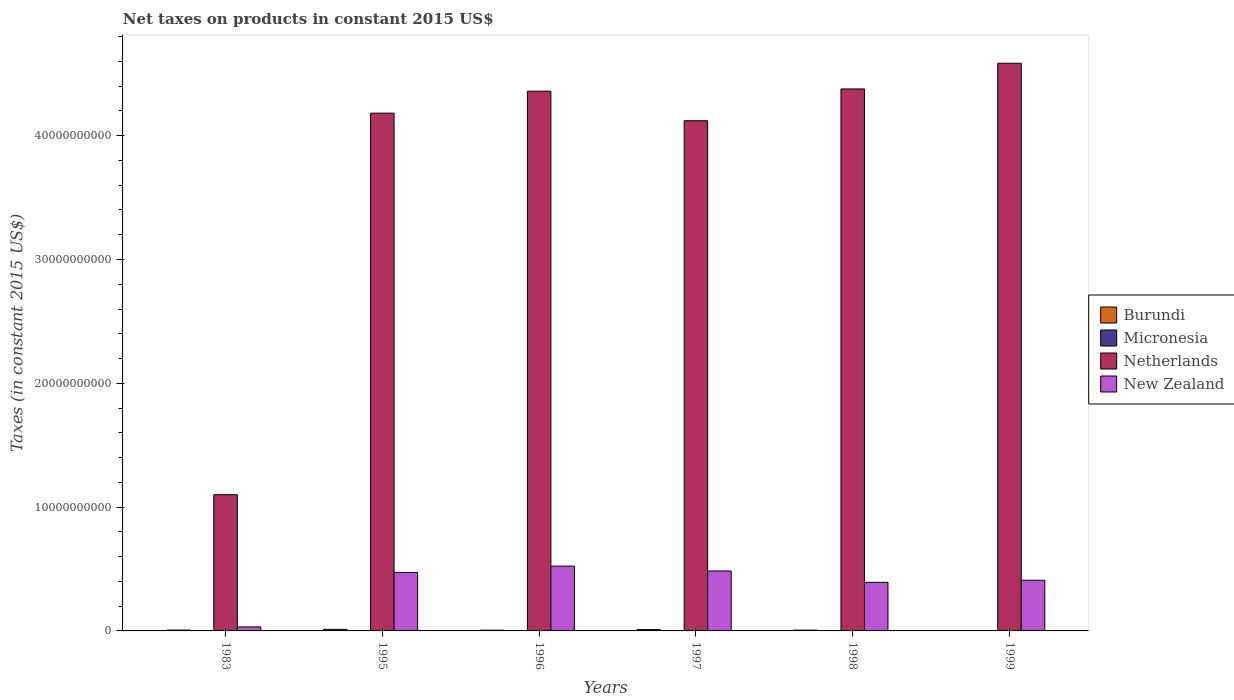How many different coloured bars are there?
Keep it short and to the point. 4. How many groups of bars are there?
Give a very brief answer. 6. Are the number of bars on each tick of the X-axis equal?
Provide a succinct answer. Yes. What is the label of the 2nd group of bars from the left?
Provide a short and direct response. 1995. What is the net taxes on products in Burundi in 1996?
Keep it short and to the point. 5.83e+07. Across all years, what is the maximum net taxes on products in New Zealand?
Provide a succinct answer. 5.23e+09. Across all years, what is the minimum net taxes on products in Micronesia?
Make the answer very short. 5.70e+06. In which year was the net taxes on products in Micronesia maximum?
Keep it short and to the point. 1999. In which year was the net taxes on products in Burundi minimum?
Offer a terse response. 1999. What is the total net taxes on products in Burundi in the graph?
Make the answer very short. 4.34e+08. What is the difference between the net taxes on products in Netherlands in 1995 and that in 1997?
Offer a terse response. 6.10e+08. What is the difference between the net taxes on products in New Zealand in 1983 and the net taxes on products in Burundi in 1995?
Your response must be concise. 1.97e+08. What is the average net taxes on products in New Zealand per year?
Keep it short and to the point. 3.86e+09. In the year 1983, what is the difference between the net taxes on products in Burundi and net taxes on products in Netherlands?
Make the answer very short. -1.09e+1. In how many years, is the net taxes on products in Micronesia greater than 10000000000 US$?
Provide a short and direct response. 0. What is the ratio of the net taxes on products in Burundi in 1983 to that in 1995?
Offer a very short reply. 0.56. What is the difference between the highest and the second highest net taxes on products in Micronesia?
Ensure brevity in your answer.  1.82e+06. What is the difference between the highest and the lowest net taxes on products in Micronesia?
Ensure brevity in your answer.  7.96e+06. In how many years, is the net taxes on products in New Zealand greater than the average net taxes on products in New Zealand taken over all years?
Your answer should be compact. 5. Is the sum of the net taxes on products in Micronesia in 1998 and 1999 greater than the maximum net taxes on products in Netherlands across all years?
Provide a succinct answer. No. Is it the case that in every year, the sum of the net taxes on products in Netherlands and net taxes on products in New Zealand is greater than the sum of net taxes on products in Micronesia and net taxes on products in Burundi?
Provide a short and direct response. No. What does the 3rd bar from the left in 1997 represents?
Ensure brevity in your answer.  Netherlands. What does the 3rd bar from the right in 1983 represents?
Keep it short and to the point. Micronesia. Are all the bars in the graph horizontal?
Make the answer very short. No. How many years are there in the graph?
Make the answer very short. 6. Are the values on the major ticks of Y-axis written in scientific E-notation?
Offer a terse response. No. Does the graph contain any zero values?
Provide a short and direct response. No. Where does the legend appear in the graph?
Offer a terse response. Center right. What is the title of the graph?
Your answer should be compact. Net taxes on products in constant 2015 US$. What is the label or title of the Y-axis?
Make the answer very short. Taxes (in constant 2015 US$). What is the Taxes (in constant 2015 US$) in Burundi in 1983?
Provide a short and direct response. 7.12e+07. What is the Taxes (in constant 2015 US$) of Micronesia in 1983?
Keep it short and to the point. 5.70e+06. What is the Taxes (in constant 2015 US$) in Netherlands in 1983?
Ensure brevity in your answer.  1.10e+1. What is the Taxes (in constant 2015 US$) of New Zealand in 1983?
Your answer should be compact. 3.24e+08. What is the Taxes (in constant 2015 US$) of Burundi in 1995?
Ensure brevity in your answer.  1.27e+08. What is the Taxes (in constant 2015 US$) of Micronesia in 1995?
Provide a short and direct response. 1.10e+07. What is the Taxes (in constant 2015 US$) in Netherlands in 1995?
Keep it short and to the point. 4.18e+1. What is the Taxes (in constant 2015 US$) of New Zealand in 1995?
Offer a terse response. 4.73e+09. What is the Taxes (in constant 2015 US$) in Burundi in 1996?
Provide a short and direct response. 5.83e+07. What is the Taxes (in constant 2015 US$) in Micronesia in 1996?
Your answer should be compact. 8.94e+06. What is the Taxes (in constant 2015 US$) of Netherlands in 1996?
Your answer should be compact. 4.36e+1. What is the Taxes (in constant 2015 US$) of New Zealand in 1996?
Your response must be concise. 5.23e+09. What is the Taxes (in constant 2015 US$) of Burundi in 1997?
Provide a succinct answer. 1.08e+08. What is the Taxes (in constant 2015 US$) of Micronesia in 1997?
Offer a terse response. 1.00e+07. What is the Taxes (in constant 2015 US$) in Netherlands in 1997?
Your answer should be very brief. 4.12e+1. What is the Taxes (in constant 2015 US$) in New Zealand in 1997?
Ensure brevity in your answer.  4.84e+09. What is the Taxes (in constant 2015 US$) of Burundi in 1998?
Offer a very short reply. 6.50e+07. What is the Taxes (in constant 2015 US$) in Micronesia in 1998?
Keep it short and to the point. 1.18e+07. What is the Taxes (in constant 2015 US$) of Netherlands in 1998?
Offer a very short reply. 4.38e+1. What is the Taxes (in constant 2015 US$) of New Zealand in 1998?
Your answer should be compact. 3.92e+09. What is the Taxes (in constant 2015 US$) in Burundi in 1999?
Make the answer very short. 4.30e+06. What is the Taxes (in constant 2015 US$) in Micronesia in 1999?
Provide a short and direct response. 1.37e+07. What is the Taxes (in constant 2015 US$) of Netherlands in 1999?
Provide a succinct answer. 4.58e+1. What is the Taxes (in constant 2015 US$) of New Zealand in 1999?
Keep it short and to the point. 4.09e+09. Across all years, what is the maximum Taxes (in constant 2015 US$) in Burundi?
Keep it short and to the point. 1.27e+08. Across all years, what is the maximum Taxes (in constant 2015 US$) of Micronesia?
Make the answer very short. 1.37e+07. Across all years, what is the maximum Taxes (in constant 2015 US$) in Netherlands?
Keep it short and to the point. 4.58e+1. Across all years, what is the maximum Taxes (in constant 2015 US$) in New Zealand?
Your answer should be very brief. 5.23e+09. Across all years, what is the minimum Taxes (in constant 2015 US$) in Burundi?
Offer a terse response. 4.30e+06. Across all years, what is the minimum Taxes (in constant 2015 US$) in Micronesia?
Give a very brief answer. 5.70e+06. Across all years, what is the minimum Taxes (in constant 2015 US$) in Netherlands?
Your answer should be compact. 1.10e+1. Across all years, what is the minimum Taxes (in constant 2015 US$) of New Zealand?
Offer a very short reply. 3.24e+08. What is the total Taxes (in constant 2015 US$) in Burundi in the graph?
Your answer should be compact. 4.34e+08. What is the total Taxes (in constant 2015 US$) in Micronesia in the graph?
Your answer should be compact. 6.12e+07. What is the total Taxes (in constant 2015 US$) of Netherlands in the graph?
Offer a terse response. 2.27e+11. What is the total Taxes (in constant 2015 US$) in New Zealand in the graph?
Give a very brief answer. 2.31e+1. What is the difference between the Taxes (in constant 2015 US$) of Burundi in 1983 and that in 1995?
Make the answer very short. -5.60e+07. What is the difference between the Taxes (in constant 2015 US$) in Micronesia in 1983 and that in 1995?
Keep it short and to the point. -5.30e+06. What is the difference between the Taxes (in constant 2015 US$) of Netherlands in 1983 and that in 1995?
Offer a terse response. -3.08e+1. What is the difference between the Taxes (in constant 2015 US$) in New Zealand in 1983 and that in 1995?
Offer a very short reply. -4.40e+09. What is the difference between the Taxes (in constant 2015 US$) of Burundi in 1983 and that in 1996?
Keep it short and to the point. 1.29e+07. What is the difference between the Taxes (in constant 2015 US$) of Micronesia in 1983 and that in 1996?
Offer a very short reply. -3.24e+06. What is the difference between the Taxes (in constant 2015 US$) of Netherlands in 1983 and that in 1996?
Ensure brevity in your answer.  -3.26e+1. What is the difference between the Taxes (in constant 2015 US$) in New Zealand in 1983 and that in 1996?
Make the answer very short. -4.91e+09. What is the difference between the Taxes (in constant 2015 US$) of Burundi in 1983 and that in 1997?
Ensure brevity in your answer.  -3.69e+07. What is the difference between the Taxes (in constant 2015 US$) in Micronesia in 1983 and that in 1997?
Offer a very short reply. -4.31e+06. What is the difference between the Taxes (in constant 2015 US$) in Netherlands in 1983 and that in 1997?
Provide a short and direct response. -3.02e+1. What is the difference between the Taxes (in constant 2015 US$) in New Zealand in 1983 and that in 1997?
Your answer should be compact. -4.52e+09. What is the difference between the Taxes (in constant 2015 US$) in Burundi in 1983 and that in 1998?
Make the answer very short. 6.21e+06. What is the difference between the Taxes (in constant 2015 US$) of Micronesia in 1983 and that in 1998?
Offer a terse response. -6.14e+06. What is the difference between the Taxes (in constant 2015 US$) in Netherlands in 1983 and that in 1998?
Give a very brief answer. -3.28e+1. What is the difference between the Taxes (in constant 2015 US$) of New Zealand in 1983 and that in 1998?
Give a very brief answer. -3.60e+09. What is the difference between the Taxes (in constant 2015 US$) in Burundi in 1983 and that in 1999?
Keep it short and to the point. 6.69e+07. What is the difference between the Taxes (in constant 2015 US$) of Micronesia in 1983 and that in 1999?
Keep it short and to the point. -7.96e+06. What is the difference between the Taxes (in constant 2015 US$) in Netherlands in 1983 and that in 1999?
Your answer should be very brief. -3.48e+1. What is the difference between the Taxes (in constant 2015 US$) in New Zealand in 1983 and that in 1999?
Give a very brief answer. -3.77e+09. What is the difference between the Taxes (in constant 2015 US$) in Burundi in 1995 and that in 1996?
Offer a terse response. 6.89e+07. What is the difference between the Taxes (in constant 2015 US$) of Micronesia in 1995 and that in 1996?
Give a very brief answer. 2.06e+06. What is the difference between the Taxes (in constant 2015 US$) in Netherlands in 1995 and that in 1996?
Make the answer very short. -1.78e+09. What is the difference between the Taxes (in constant 2015 US$) in New Zealand in 1995 and that in 1996?
Make the answer very short. -5.06e+08. What is the difference between the Taxes (in constant 2015 US$) in Burundi in 1995 and that in 1997?
Offer a terse response. 1.91e+07. What is the difference between the Taxes (in constant 2015 US$) of Micronesia in 1995 and that in 1997?
Offer a very short reply. 9.87e+05. What is the difference between the Taxes (in constant 2015 US$) in Netherlands in 1995 and that in 1997?
Provide a succinct answer. 6.10e+08. What is the difference between the Taxes (in constant 2015 US$) of New Zealand in 1995 and that in 1997?
Offer a terse response. -1.17e+08. What is the difference between the Taxes (in constant 2015 US$) of Burundi in 1995 and that in 1998?
Offer a very short reply. 6.22e+07. What is the difference between the Taxes (in constant 2015 US$) in Micronesia in 1995 and that in 1998?
Give a very brief answer. -8.42e+05. What is the difference between the Taxes (in constant 2015 US$) in Netherlands in 1995 and that in 1998?
Your answer should be very brief. -1.96e+09. What is the difference between the Taxes (in constant 2015 US$) in New Zealand in 1995 and that in 1998?
Your answer should be compact. 8.03e+08. What is the difference between the Taxes (in constant 2015 US$) in Burundi in 1995 and that in 1999?
Offer a very short reply. 1.23e+08. What is the difference between the Taxes (in constant 2015 US$) in Micronesia in 1995 and that in 1999?
Provide a short and direct response. -2.66e+06. What is the difference between the Taxes (in constant 2015 US$) in Netherlands in 1995 and that in 1999?
Your response must be concise. -4.03e+09. What is the difference between the Taxes (in constant 2015 US$) of New Zealand in 1995 and that in 1999?
Your response must be concise. 6.34e+08. What is the difference between the Taxes (in constant 2015 US$) in Burundi in 1996 and that in 1997?
Your answer should be compact. -4.98e+07. What is the difference between the Taxes (in constant 2015 US$) of Micronesia in 1996 and that in 1997?
Offer a very short reply. -1.07e+06. What is the difference between the Taxes (in constant 2015 US$) of Netherlands in 1996 and that in 1997?
Make the answer very short. 2.39e+09. What is the difference between the Taxes (in constant 2015 US$) of New Zealand in 1996 and that in 1997?
Your answer should be compact. 3.89e+08. What is the difference between the Taxes (in constant 2015 US$) in Burundi in 1996 and that in 1998?
Keep it short and to the point. -6.66e+06. What is the difference between the Taxes (in constant 2015 US$) of Micronesia in 1996 and that in 1998?
Provide a succinct answer. -2.90e+06. What is the difference between the Taxes (in constant 2015 US$) of Netherlands in 1996 and that in 1998?
Ensure brevity in your answer.  -1.81e+08. What is the difference between the Taxes (in constant 2015 US$) of New Zealand in 1996 and that in 1998?
Your response must be concise. 1.31e+09. What is the difference between the Taxes (in constant 2015 US$) of Burundi in 1996 and that in 1999?
Your answer should be compact. 5.40e+07. What is the difference between the Taxes (in constant 2015 US$) in Micronesia in 1996 and that in 1999?
Make the answer very short. -4.72e+06. What is the difference between the Taxes (in constant 2015 US$) in Netherlands in 1996 and that in 1999?
Offer a very short reply. -2.25e+09. What is the difference between the Taxes (in constant 2015 US$) of New Zealand in 1996 and that in 1999?
Provide a succinct answer. 1.14e+09. What is the difference between the Taxes (in constant 2015 US$) in Burundi in 1997 and that in 1998?
Your answer should be compact. 4.32e+07. What is the difference between the Taxes (in constant 2015 US$) of Micronesia in 1997 and that in 1998?
Your answer should be compact. -1.83e+06. What is the difference between the Taxes (in constant 2015 US$) in Netherlands in 1997 and that in 1998?
Make the answer very short. -2.57e+09. What is the difference between the Taxes (in constant 2015 US$) in New Zealand in 1997 and that in 1998?
Offer a terse response. 9.21e+08. What is the difference between the Taxes (in constant 2015 US$) of Burundi in 1997 and that in 1999?
Provide a succinct answer. 1.04e+08. What is the difference between the Taxes (in constant 2015 US$) in Micronesia in 1997 and that in 1999?
Make the answer very short. -3.65e+06. What is the difference between the Taxes (in constant 2015 US$) in Netherlands in 1997 and that in 1999?
Make the answer very short. -4.64e+09. What is the difference between the Taxes (in constant 2015 US$) in New Zealand in 1997 and that in 1999?
Offer a terse response. 7.51e+08. What is the difference between the Taxes (in constant 2015 US$) of Burundi in 1998 and that in 1999?
Give a very brief answer. 6.07e+07. What is the difference between the Taxes (in constant 2015 US$) in Micronesia in 1998 and that in 1999?
Your response must be concise. -1.82e+06. What is the difference between the Taxes (in constant 2015 US$) in Netherlands in 1998 and that in 1999?
Ensure brevity in your answer.  -2.07e+09. What is the difference between the Taxes (in constant 2015 US$) in New Zealand in 1998 and that in 1999?
Offer a very short reply. -1.69e+08. What is the difference between the Taxes (in constant 2015 US$) in Burundi in 1983 and the Taxes (in constant 2015 US$) in Micronesia in 1995?
Your answer should be compact. 6.02e+07. What is the difference between the Taxes (in constant 2015 US$) of Burundi in 1983 and the Taxes (in constant 2015 US$) of Netherlands in 1995?
Provide a succinct answer. -4.17e+1. What is the difference between the Taxes (in constant 2015 US$) of Burundi in 1983 and the Taxes (in constant 2015 US$) of New Zealand in 1995?
Give a very brief answer. -4.65e+09. What is the difference between the Taxes (in constant 2015 US$) of Micronesia in 1983 and the Taxes (in constant 2015 US$) of Netherlands in 1995?
Offer a terse response. -4.18e+1. What is the difference between the Taxes (in constant 2015 US$) of Micronesia in 1983 and the Taxes (in constant 2015 US$) of New Zealand in 1995?
Your answer should be very brief. -4.72e+09. What is the difference between the Taxes (in constant 2015 US$) of Netherlands in 1983 and the Taxes (in constant 2015 US$) of New Zealand in 1995?
Give a very brief answer. 6.28e+09. What is the difference between the Taxes (in constant 2015 US$) of Burundi in 1983 and the Taxes (in constant 2015 US$) of Micronesia in 1996?
Give a very brief answer. 6.23e+07. What is the difference between the Taxes (in constant 2015 US$) in Burundi in 1983 and the Taxes (in constant 2015 US$) in Netherlands in 1996?
Your answer should be compact. -4.35e+1. What is the difference between the Taxes (in constant 2015 US$) of Burundi in 1983 and the Taxes (in constant 2015 US$) of New Zealand in 1996?
Provide a short and direct response. -5.16e+09. What is the difference between the Taxes (in constant 2015 US$) of Micronesia in 1983 and the Taxes (in constant 2015 US$) of Netherlands in 1996?
Your response must be concise. -4.36e+1. What is the difference between the Taxes (in constant 2015 US$) of Micronesia in 1983 and the Taxes (in constant 2015 US$) of New Zealand in 1996?
Ensure brevity in your answer.  -5.23e+09. What is the difference between the Taxes (in constant 2015 US$) of Netherlands in 1983 and the Taxes (in constant 2015 US$) of New Zealand in 1996?
Give a very brief answer. 5.77e+09. What is the difference between the Taxes (in constant 2015 US$) in Burundi in 1983 and the Taxes (in constant 2015 US$) in Micronesia in 1997?
Your answer should be compact. 6.12e+07. What is the difference between the Taxes (in constant 2015 US$) in Burundi in 1983 and the Taxes (in constant 2015 US$) in Netherlands in 1997?
Provide a short and direct response. -4.11e+1. What is the difference between the Taxes (in constant 2015 US$) in Burundi in 1983 and the Taxes (in constant 2015 US$) in New Zealand in 1997?
Keep it short and to the point. -4.77e+09. What is the difference between the Taxes (in constant 2015 US$) of Micronesia in 1983 and the Taxes (in constant 2015 US$) of Netherlands in 1997?
Ensure brevity in your answer.  -4.12e+1. What is the difference between the Taxes (in constant 2015 US$) in Micronesia in 1983 and the Taxes (in constant 2015 US$) in New Zealand in 1997?
Your answer should be very brief. -4.84e+09. What is the difference between the Taxes (in constant 2015 US$) in Netherlands in 1983 and the Taxes (in constant 2015 US$) in New Zealand in 1997?
Give a very brief answer. 6.16e+09. What is the difference between the Taxes (in constant 2015 US$) in Burundi in 1983 and the Taxes (in constant 2015 US$) in Micronesia in 1998?
Offer a terse response. 5.94e+07. What is the difference between the Taxes (in constant 2015 US$) in Burundi in 1983 and the Taxes (in constant 2015 US$) in Netherlands in 1998?
Offer a terse response. -4.37e+1. What is the difference between the Taxes (in constant 2015 US$) in Burundi in 1983 and the Taxes (in constant 2015 US$) in New Zealand in 1998?
Provide a succinct answer. -3.85e+09. What is the difference between the Taxes (in constant 2015 US$) in Micronesia in 1983 and the Taxes (in constant 2015 US$) in Netherlands in 1998?
Your answer should be very brief. -4.38e+1. What is the difference between the Taxes (in constant 2015 US$) in Micronesia in 1983 and the Taxes (in constant 2015 US$) in New Zealand in 1998?
Your answer should be compact. -3.92e+09. What is the difference between the Taxes (in constant 2015 US$) in Netherlands in 1983 and the Taxes (in constant 2015 US$) in New Zealand in 1998?
Keep it short and to the point. 7.08e+09. What is the difference between the Taxes (in constant 2015 US$) in Burundi in 1983 and the Taxes (in constant 2015 US$) in Micronesia in 1999?
Your answer should be very brief. 5.75e+07. What is the difference between the Taxes (in constant 2015 US$) in Burundi in 1983 and the Taxes (in constant 2015 US$) in Netherlands in 1999?
Make the answer very short. -4.58e+1. What is the difference between the Taxes (in constant 2015 US$) of Burundi in 1983 and the Taxes (in constant 2015 US$) of New Zealand in 1999?
Your answer should be compact. -4.02e+09. What is the difference between the Taxes (in constant 2015 US$) of Micronesia in 1983 and the Taxes (in constant 2015 US$) of Netherlands in 1999?
Give a very brief answer. -4.58e+1. What is the difference between the Taxes (in constant 2015 US$) in Micronesia in 1983 and the Taxes (in constant 2015 US$) in New Zealand in 1999?
Your answer should be very brief. -4.09e+09. What is the difference between the Taxes (in constant 2015 US$) of Netherlands in 1983 and the Taxes (in constant 2015 US$) of New Zealand in 1999?
Provide a short and direct response. 6.91e+09. What is the difference between the Taxes (in constant 2015 US$) in Burundi in 1995 and the Taxes (in constant 2015 US$) in Micronesia in 1996?
Give a very brief answer. 1.18e+08. What is the difference between the Taxes (in constant 2015 US$) in Burundi in 1995 and the Taxes (in constant 2015 US$) in Netherlands in 1996?
Your answer should be very brief. -4.35e+1. What is the difference between the Taxes (in constant 2015 US$) in Burundi in 1995 and the Taxes (in constant 2015 US$) in New Zealand in 1996?
Make the answer very short. -5.10e+09. What is the difference between the Taxes (in constant 2015 US$) in Micronesia in 1995 and the Taxes (in constant 2015 US$) in Netherlands in 1996?
Provide a short and direct response. -4.36e+1. What is the difference between the Taxes (in constant 2015 US$) in Micronesia in 1995 and the Taxes (in constant 2015 US$) in New Zealand in 1996?
Your answer should be very brief. -5.22e+09. What is the difference between the Taxes (in constant 2015 US$) in Netherlands in 1995 and the Taxes (in constant 2015 US$) in New Zealand in 1996?
Offer a very short reply. 3.66e+1. What is the difference between the Taxes (in constant 2015 US$) in Burundi in 1995 and the Taxes (in constant 2015 US$) in Micronesia in 1997?
Keep it short and to the point. 1.17e+08. What is the difference between the Taxes (in constant 2015 US$) in Burundi in 1995 and the Taxes (in constant 2015 US$) in Netherlands in 1997?
Offer a terse response. -4.11e+1. What is the difference between the Taxes (in constant 2015 US$) of Burundi in 1995 and the Taxes (in constant 2015 US$) of New Zealand in 1997?
Provide a short and direct response. -4.72e+09. What is the difference between the Taxes (in constant 2015 US$) in Micronesia in 1995 and the Taxes (in constant 2015 US$) in Netherlands in 1997?
Your response must be concise. -4.12e+1. What is the difference between the Taxes (in constant 2015 US$) of Micronesia in 1995 and the Taxes (in constant 2015 US$) of New Zealand in 1997?
Keep it short and to the point. -4.83e+09. What is the difference between the Taxes (in constant 2015 US$) of Netherlands in 1995 and the Taxes (in constant 2015 US$) of New Zealand in 1997?
Your answer should be compact. 3.70e+1. What is the difference between the Taxes (in constant 2015 US$) of Burundi in 1995 and the Taxes (in constant 2015 US$) of Micronesia in 1998?
Make the answer very short. 1.15e+08. What is the difference between the Taxes (in constant 2015 US$) in Burundi in 1995 and the Taxes (in constant 2015 US$) in Netherlands in 1998?
Your answer should be compact. -4.36e+1. What is the difference between the Taxes (in constant 2015 US$) in Burundi in 1995 and the Taxes (in constant 2015 US$) in New Zealand in 1998?
Your answer should be very brief. -3.80e+09. What is the difference between the Taxes (in constant 2015 US$) in Micronesia in 1995 and the Taxes (in constant 2015 US$) in Netherlands in 1998?
Offer a terse response. -4.38e+1. What is the difference between the Taxes (in constant 2015 US$) of Micronesia in 1995 and the Taxes (in constant 2015 US$) of New Zealand in 1998?
Offer a very short reply. -3.91e+09. What is the difference between the Taxes (in constant 2015 US$) in Netherlands in 1995 and the Taxes (in constant 2015 US$) in New Zealand in 1998?
Offer a very short reply. 3.79e+1. What is the difference between the Taxes (in constant 2015 US$) in Burundi in 1995 and the Taxes (in constant 2015 US$) in Micronesia in 1999?
Your answer should be very brief. 1.14e+08. What is the difference between the Taxes (in constant 2015 US$) in Burundi in 1995 and the Taxes (in constant 2015 US$) in Netherlands in 1999?
Your answer should be very brief. -4.57e+1. What is the difference between the Taxes (in constant 2015 US$) in Burundi in 1995 and the Taxes (in constant 2015 US$) in New Zealand in 1999?
Offer a very short reply. -3.96e+09. What is the difference between the Taxes (in constant 2015 US$) of Micronesia in 1995 and the Taxes (in constant 2015 US$) of Netherlands in 1999?
Your answer should be compact. -4.58e+1. What is the difference between the Taxes (in constant 2015 US$) in Micronesia in 1995 and the Taxes (in constant 2015 US$) in New Zealand in 1999?
Your answer should be compact. -4.08e+09. What is the difference between the Taxes (in constant 2015 US$) of Netherlands in 1995 and the Taxes (in constant 2015 US$) of New Zealand in 1999?
Offer a terse response. 3.77e+1. What is the difference between the Taxes (in constant 2015 US$) in Burundi in 1996 and the Taxes (in constant 2015 US$) in Micronesia in 1997?
Offer a very short reply. 4.83e+07. What is the difference between the Taxes (in constant 2015 US$) of Burundi in 1996 and the Taxes (in constant 2015 US$) of Netherlands in 1997?
Offer a very short reply. -4.11e+1. What is the difference between the Taxes (in constant 2015 US$) of Burundi in 1996 and the Taxes (in constant 2015 US$) of New Zealand in 1997?
Offer a very short reply. -4.78e+09. What is the difference between the Taxes (in constant 2015 US$) of Micronesia in 1996 and the Taxes (in constant 2015 US$) of Netherlands in 1997?
Your answer should be compact. -4.12e+1. What is the difference between the Taxes (in constant 2015 US$) in Micronesia in 1996 and the Taxes (in constant 2015 US$) in New Zealand in 1997?
Your response must be concise. -4.83e+09. What is the difference between the Taxes (in constant 2015 US$) in Netherlands in 1996 and the Taxes (in constant 2015 US$) in New Zealand in 1997?
Give a very brief answer. 3.88e+1. What is the difference between the Taxes (in constant 2015 US$) of Burundi in 1996 and the Taxes (in constant 2015 US$) of Micronesia in 1998?
Ensure brevity in your answer.  4.65e+07. What is the difference between the Taxes (in constant 2015 US$) of Burundi in 1996 and the Taxes (in constant 2015 US$) of Netherlands in 1998?
Your answer should be compact. -4.37e+1. What is the difference between the Taxes (in constant 2015 US$) in Burundi in 1996 and the Taxes (in constant 2015 US$) in New Zealand in 1998?
Offer a terse response. -3.86e+09. What is the difference between the Taxes (in constant 2015 US$) in Micronesia in 1996 and the Taxes (in constant 2015 US$) in Netherlands in 1998?
Keep it short and to the point. -4.38e+1. What is the difference between the Taxes (in constant 2015 US$) in Micronesia in 1996 and the Taxes (in constant 2015 US$) in New Zealand in 1998?
Make the answer very short. -3.91e+09. What is the difference between the Taxes (in constant 2015 US$) of Netherlands in 1996 and the Taxes (in constant 2015 US$) of New Zealand in 1998?
Provide a short and direct response. 3.97e+1. What is the difference between the Taxes (in constant 2015 US$) of Burundi in 1996 and the Taxes (in constant 2015 US$) of Micronesia in 1999?
Provide a short and direct response. 4.47e+07. What is the difference between the Taxes (in constant 2015 US$) in Burundi in 1996 and the Taxes (in constant 2015 US$) in Netherlands in 1999?
Provide a short and direct response. -4.58e+1. What is the difference between the Taxes (in constant 2015 US$) in Burundi in 1996 and the Taxes (in constant 2015 US$) in New Zealand in 1999?
Your answer should be very brief. -4.03e+09. What is the difference between the Taxes (in constant 2015 US$) of Micronesia in 1996 and the Taxes (in constant 2015 US$) of Netherlands in 1999?
Your response must be concise. -4.58e+1. What is the difference between the Taxes (in constant 2015 US$) of Micronesia in 1996 and the Taxes (in constant 2015 US$) of New Zealand in 1999?
Make the answer very short. -4.08e+09. What is the difference between the Taxes (in constant 2015 US$) of Netherlands in 1996 and the Taxes (in constant 2015 US$) of New Zealand in 1999?
Offer a very short reply. 3.95e+1. What is the difference between the Taxes (in constant 2015 US$) of Burundi in 1997 and the Taxes (in constant 2015 US$) of Micronesia in 1998?
Offer a terse response. 9.63e+07. What is the difference between the Taxes (in constant 2015 US$) in Burundi in 1997 and the Taxes (in constant 2015 US$) in Netherlands in 1998?
Your answer should be compact. -4.37e+1. What is the difference between the Taxes (in constant 2015 US$) in Burundi in 1997 and the Taxes (in constant 2015 US$) in New Zealand in 1998?
Make the answer very short. -3.81e+09. What is the difference between the Taxes (in constant 2015 US$) in Micronesia in 1997 and the Taxes (in constant 2015 US$) in Netherlands in 1998?
Offer a very short reply. -4.38e+1. What is the difference between the Taxes (in constant 2015 US$) of Micronesia in 1997 and the Taxes (in constant 2015 US$) of New Zealand in 1998?
Your answer should be very brief. -3.91e+09. What is the difference between the Taxes (in constant 2015 US$) of Netherlands in 1997 and the Taxes (in constant 2015 US$) of New Zealand in 1998?
Your response must be concise. 3.73e+1. What is the difference between the Taxes (in constant 2015 US$) in Burundi in 1997 and the Taxes (in constant 2015 US$) in Micronesia in 1999?
Ensure brevity in your answer.  9.45e+07. What is the difference between the Taxes (in constant 2015 US$) of Burundi in 1997 and the Taxes (in constant 2015 US$) of Netherlands in 1999?
Make the answer very short. -4.57e+1. What is the difference between the Taxes (in constant 2015 US$) of Burundi in 1997 and the Taxes (in constant 2015 US$) of New Zealand in 1999?
Give a very brief answer. -3.98e+09. What is the difference between the Taxes (in constant 2015 US$) of Micronesia in 1997 and the Taxes (in constant 2015 US$) of Netherlands in 1999?
Make the answer very short. -4.58e+1. What is the difference between the Taxes (in constant 2015 US$) in Micronesia in 1997 and the Taxes (in constant 2015 US$) in New Zealand in 1999?
Offer a terse response. -4.08e+09. What is the difference between the Taxes (in constant 2015 US$) of Netherlands in 1997 and the Taxes (in constant 2015 US$) of New Zealand in 1999?
Ensure brevity in your answer.  3.71e+1. What is the difference between the Taxes (in constant 2015 US$) of Burundi in 1998 and the Taxes (in constant 2015 US$) of Micronesia in 1999?
Offer a very short reply. 5.13e+07. What is the difference between the Taxes (in constant 2015 US$) in Burundi in 1998 and the Taxes (in constant 2015 US$) in Netherlands in 1999?
Provide a short and direct response. -4.58e+1. What is the difference between the Taxes (in constant 2015 US$) of Burundi in 1998 and the Taxes (in constant 2015 US$) of New Zealand in 1999?
Offer a terse response. -4.03e+09. What is the difference between the Taxes (in constant 2015 US$) of Micronesia in 1998 and the Taxes (in constant 2015 US$) of Netherlands in 1999?
Keep it short and to the point. -4.58e+1. What is the difference between the Taxes (in constant 2015 US$) in Micronesia in 1998 and the Taxes (in constant 2015 US$) in New Zealand in 1999?
Provide a short and direct response. -4.08e+09. What is the difference between the Taxes (in constant 2015 US$) of Netherlands in 1998 and the Taxes (in constant 2015 US$) of New Zealand in 1999?
Offer a very short reply. 3.97e+1. What is the average Taxes (in constant 2015 US$) of Burundi per year?
Offer a very short reply. 7.24e+07. What is the average Taxes (in constant 2015 US$) of Micronesia per year?
Keep it short and to the point. 1.02e+07. What is the average Taxes (in constant 2015 US$) in Netherlands per year?
Give a very brief answer. 3.79e+1. What is the average Taxes (in constant 2015 US$) of New Zealand per year?
Provide a short and direct response. 3.86e+09. In the year 1983, what is the difference between the Taxes (in constant 2015 US$) in Burundi and Taxes (in constant 2015 US$) in Micronesia?
Give a very brief answer. 6.55e+07. In the year 1983, what is the difference between the Taxes (in constant 2015 US$) in Burundi and Taxes (in constant 2015 US$) in Netherlands?
Give a very brief answer. -1.09e+1. In the year 1983, what is the difference between the Taxes (in constant 2015 US$) in Burundi and Taxes (in constant 2015 US$) in New Zealand?
Provide a short and direct response. -2.53e+08. In the year 1983, what is the difference between the Taxes (in constant 2015 US$) in Micronesia and Taxes (in constant 2015 US$) in Netherlands?
Your response must be concise. -1.10e+1. In the year 1983, what is the difference between the Taxes (in constant 2015 US$) of Micronesia and Taxes (in constant 2015 US$) of New Zealand?
Your answer should be very brief. -3.19e+08. In the year 1983, what is the difference between the Taxes (in constant 2015 US$) of Netherlands and Taxes (in constant 2015 US$) of New Zealand?
Ensure brevity in your answer.  1.07e+1. In the year 1995, what is the difference between the Taxes (in constant 2015 US$) of Burundi and Taxes (in constant 2015 US$) of Micronesia?
Make the answer very short. 1.16e+08. In the year 1995, what is the difference between the Taxes (in constant 2015 US$) of Burundi and Taxes (in constant 2015 US$) of Netherlands?
Offer a terse response. -4.17e+1. In the year 1995, what is the difference between the Taxes (in constant 2015 US$) in Burundi and Taxes (in constant 2015 US$) in New Zealand?
Give a very brief answer. -4.60e+09. In the year 1995, what is the difference between the Taxes (in constant 2015 US$) of Micronesia and Taxes (in constant 2015 US$) of Netherlands?
Keep it short and to the point. -4.18e+1. In the year 1995, what is the difference between the Taxes (in constant 2015 US$) of Micronesia and Taxes (in constant 2015 US$) of New Zealand?
Provide a succinct answer. -4.71e+09. In the year 1995, what is the difference between the Taxes (in constant 2015 US$) in Netherlands and Taxes (in constant 2015 US$) in New Zealand?
Keep it short and to the point. 3.71e+1. In the year 1996, what is the difference between the Taxes (in constant 2015 US$) in Burundi and Taxes (in constant 2015 US$) in Micronesia?
Give a very brief answer. 4.94e+07. In the year 1996, what is the difference between the Taxes (in constant 2015 US$) of Burundi and Taxes (in constant 2015 US$) of Netherlands?
Provide a short and direct response. -4.35e+1. In the year 1996, what is the difference between the Taxes (in constant 2015 US$) in Burundi and Taxes (in constant 2015 US$) in New Zealand?
Offer a very short reply. -5.17e+09. In the year 1996, what is the difference between the Taxes (in constant 2015 US$) in Micronesia and Taxes (in constant 2015 US$) in Netherlands?
Offer a very short reply. -4.36e+1. In the year 1996, what is the difference between the Taxes (in constant 2015 US$) in Micronesia and Taxes (in constant 2015 US$) in New Zealand?
Provide a short and direct response. -5.22e+09. In the year 1996, what is the difference between the Taxes (in constant 2015 US$) in Netherlands and Taxes (in constant 2015 US$) in New Zealand?
Keep it short and to the point. 3.84e+1. In the year 1997, what is the difference between the Taxes (in constant 2015 US$) in Burundi and Taxes (in constant 2015 US$) in Micronesia?
Make the answer very short. 9.81e+07. In the year 1997, what is the difference between the Taxes (in constant 2015 US$) in Burundi and Taxes (in constant 2015 US$) in Netherlands?
Your answer should be compact. -4.11e+1. In the year 1997, what is the difference between the Taxes (in constant 2015 US$) of Burundi and Taxes (in constant 2015 US$) of New Zealand?
Ensure brevity in your answer.  -4.74e+09. In the year 1997, what is the difference between the Taxes (in constant 2015 US$) of Micronesia and Taxes (in constant 2015 US$) of Netherlands?
Keep it short and to the point. -4.12e+1. In the year 1997, what is the difference between the Taxes (in constant 2015 US$) in Micronesia and Taxes (in constant 2015 US$) in New Zealand?
Offer a terse response. -4.83e+09. In the year 1997, what is the difference between the Taxes (in constant 2015 US$) in Netherlands and Taxes (in constant 2015 US$) in New Zealand?
Ensure brevity in your answer.  3.64e+1. In the year 1998, what is the difference between the Taxes (in constant 2015 US$) of Burundi and Taxes (in constant 2015 US$) of Micronesia?
Your response must be concise. 5.32e+07. In the year 1998, what is the difference between the Taxes (in constant 2015 US$) in Burundi and Taxes (in constant 2015 US$) in Netherlands?
Your answer should be compact. -4.37e+1. In the year 1998, what is the difference between the Taxes (in constant 2015 US$) in Burundi and Taxes (in constant 2015 US$) in New Zealand?
Provide a short and direct response. -3.86e+09. In the year 1998, what is the difference between the Taxes (in constant 2015 US$) in Micronesia and Taxes (in constant 2015 US$) in Netherlands?
Your answer should be compact. -4.38e+1. In the year 1998, what is the difference between the Taxes (in constant 2015 US$) in Micronesia and Taxes (in constant 2015 US$) in New Zealand?
Your answer should be very brief. -3.91e+09. In the year 1998, what is the difference between the Taxes (in constant 2015 US$) of Netherlands and Taxes (in constant 2015 US$) of New Zealand?
Make the answer very short. 3.99e+1. In the year 1999, what is the difference between the Taxes (in constant 2015 US$) in Burundi and Taxes (in constant 2015 US$) in Micronesia?
Your answer should be compact. -9.37e+06. In the year 1999, what is the difference between the Taxes (in constant 2015 US$) in Burundi and Taxes (in constant 2015 US$) in Netherlands?
Make the answer very short. -4.58e+1. In the year 1999, what is the difference between the Taxes (in constant 2015 US$) of Burundi and Taxes (in constant 2015 US$) of New Zealand?
Your response must be concise. -4.09e+09. In the year 1999, what is the difference between the Taxes (in constant 2015 US$) in Micronesia and Taxes (in constant 2015 US$) in Netherlands?
Your answer should be very brief. -4.58e+1. In the year 1999, what is the difference between the Taxes (in constant 2015 US$) of Micronesia and Taxes (in constant 2015 US$) of New Zealand?
Provide a short and direct response. -4.08e+09. In the year 1999, what is the difference between the Taxes (in constant 2015 US$) in Netherlands and Taxes (in constant 2015 US$) in New Zealand?
Offer a very short reply. 4.18e+1. What is the ratio of the Taxes (in constant 2015 US$) in Burundi in 1983 to that in 1995?
Your answer should be very brief. 0.56. What is the ratio of the Taxes (in constant 2015 US$) in Micronesia in 1983 to that in 1995?
Keep it short and to the point. 0.52. What is the ratio of the Taxes (in constant 2015 US$) of Netherlands in 1983 to that in 1995?
Ensure brevity in your answer.  0.26. What is the ratio of the Taxes (in constant 2015 US$) in New Zealand in 1983 to that in 1995?
Your response must be concise. 0.07. What is the ratio of the Taxes (in constant 2015 US$) of Burundi in 1983 to that in 1996?
Offer a terse response. 1.22. What is the ratio of the Taxes (in constant 2015 US$) of Micronesia in 1983 to that in 1996?
Ensure brevity in your answer.  0.64. What is the ratio of the Taxes (in constant 2015 US$) in Netherlands in 1983 to that in 1996?
Give a very brief answer. 0.25. What is the ratio of the Taxes (in constant 2015 US$) in New Zealand in 1983 to that in 1996?
Your response must be concise. 0.06. What is the ratio of the Taxes (in constant 2015 US$) of Burundi in 1983 to that in 1997?
Provide a short and direct response. 0.66. What is the ratio of the Taxes (in constant 2015 US$) of Micronesia in 1983 to that in 1997?
Offer a terse response. 0.57. What is the ratio of the Taxes (in constant 2015 US$) of Netherlands in 1983 to that in 1997?
Make the answer very short. 0.27. What is the ratio of the Taxes (in constant 2015 US$) of New Zealand in 1983 to that in 1997?
Make the answer very short. 0.07. What is the ratio of the Taxes (in constant 2015 US$) of Burundi in 1983 to that in 1998?
Your response must be concise. 1.1. What is the ratio of the Taxes (in constant 2015 US$) in Micronesia in 1983 to that in 1998?
Offer a very short reply. 0.48. What is the ratio of the Taxes (in constant 2015 US$) in Netherlands in 1983 to that in 1998?
Your answer should be very brief. 0.25. What is the ratio of the Taxes (in constant 2015 US$) in New Zealand in 1983 to that in 1998?
Give a very brief answer. 0.08. What is the ratio of the Taxes (in constant 2015 US$) of Burundi in 1983 to that in 1999?
Ensure brevity in your answer.  16.57. What is the ratio of the Taxes (in constant 2015 US$) in Micronesia in 1983 to that in 1999?
Make the answer very short. 0.42. What is the ratio of the Taxes (in constant 2015 US$) of Netherlands in 1983 to that in 1999?
Offer a very short reply. 0.24. What is the ratio of the Taxes (in constant 2015 US$) in New Zealand in 1983 to that in 1999?
Provide a short and direct response. 0.08. What is the ratio of the Taxes (in constant 2015 US$) of Burundi in 1995 to that in 1996?
Your answer should be very brief. 2.18. What is the ratio of the Taxes (in constant 2015 US$) of Micronesia in 1995 to that in 1996?
Your answer should be compact. 1.23. What is the ratio of the Taxes (in constant 2015 US$) of Netherlands in 1995 to that in 1996?
Keep it short and to the point. 0.96. What is the ratio of the Taxes (in constant 2015 US$) of New Zealand in 1995 to that in 1996?
Ensure brevity in your answer.  0.9. What is the ratio of the Taxes (in constant 2015 US$) of Burundi in 1995 to that in 1997?
Your answer should be very brief. 1.18. What is the ratio of the Taxes (in constant 2015 US$) of Micronesia in 1995 to that in 1997?
Your answer should be compact. 1.1. What is the ratio of the Taxes (in constant 2015 US$) of Netherlands in 1995 to that in 1997?
Provide a succinct answer. 1.01. What is the ratio of the Taxes (in constant 2015 US$) of New Zealand in 1995 to that in 1997?
Give a very brief answer. 0.98. What is the ratio of the Taxes (in constant 2015 US$) of Burundi in 1995 to that in 1998?
Your answer should be very brief. 1.96. What is the ratio of the Taxes (in constant 2015 US$) of Micronesia in 1995 to that in 1998?
Offer a terse response. 0.93. What is the ratio of the Taxes (in constant 2015 US$) of Netherlands in 1995 to that in 1998?
Offer a terse response. 0.96. What is the ratio of the Taxes (in constant 2015 US$) of New Zealand in 1995 to that in 1998?
Ensure brevity in your answer.  1.2. What is the ratio of the Taxes (in constant 2015 US$) of Burundi in 1995 to that in 1999?
Make the answer very short. 29.61. What is the ratio of the Taxes (in constant 2015 US$) of Micronesia in 1995 to that in 1999?
Make the answer very short. 0.81. What is the ratio of the Taxes (in constant 2015 US$) of Netherlands in 1995 to that in 1999?
Offer a very short reply. 0.91. What is the ratio of the Taxes (in constant 2015 US$) in New Zealand in 1995 to that in 1999?
Provide a short and direct response. 1.16. What is the ratio of the Taxes (in constant 2015 US$) in Burundi in 1996 to that in 1997?
Provide a succinct answer. 0.54. What is the ratio of the Taxes (in constant 2015 US$) of Micronesia in 1996 to that in 1997?
Your answer should be compact. 0.89. What is the ratio of the Taxes (in constant 2015 US$) of Netherlands in 1996 to that in 1997?
Your answer should be compact. 1.06. What is the ratio of the Taxes (in constant 2015 US$) of New Zealand in 1996 to that in 1997?
Your answer should be compact. 1.08. What is the ratio of the Taxes (in constant 2015 US$) of Burundi in 1996 to that in 1998?
Your answer should be very brief. 0.9. What is the ratio of the Taxes (in constant 2015 US$) of Micronesia in 1996 to that in 1998?
Provide a succinct answer. 0.75. What is the ratio of the Taxes (in constant 2015 US$) in Netherlands in 1996 to that in 1998?
Your answer should be very brief. 1. What is the ratio of the Taxes (in constant 2015 US$) of New Zealand in 1996 to that in 1998?
Keep it short and to the point. 1.33. What is the ratio of the Taxes (in constant 2015 US$) in Burundi in 1996 to that in 1999?
Offer a very short reply. 13.58. What is the ratio of the Taxes (in constant 2015 US$) of Micronesia in 1996 to that in 1999?
Your answer should be compact. 0.65. What is the ratio of the Taxes (in constant 2015 US$) of Netherlands in 1996 to that in 1999?
Ensure brevity in your answer.  0.95. What is the ratio of the Taxes (in constant 2015 US$) of New Zealand in 1996 to that in 1999?
Your answer should be compact. 1.28. What is the ratio of the Taxes (in constant 2015 US$) in Burundi in 1997 to that in 1998?
Make the answer very short. 1.66. What is the ratio of the Taxes (in constant 2015 US$) of Micronesia in 1997 to that in 1998?
Provide a succinct answer. 0.85. What is the ratio of the Taxes (in constant 2015 US$) of Netherlands in 1997 to that in 1998?
Provide a short and direct response. 0.94. What is the ratio of the Taxes (in constant 2015 US$) of New Zealand in 1997 to that in 1998?
Offer a terse response. 1.23. What is the ratio of the Taxes (in constant 2015 US$) in Burundi in 1997 to that in 1999?
Offer a terse response. 25.17. What is the ratio of the Taxes (in constant 2015 US$) of Micronesia in 1997 to that in 1999?
Provide a succinct answer. 0.73. What is the ratio of the Taxes (in constant 2015 US$) of Netherlands in 1997 to that in 1999?
Your response must be concise. 0.9. What is the ratio of the Taxes (in constant 2015 US$) of New Zealand in 1997 to that in 1999?
Keep it short and to the point. 1.18. What is the ratio of the Taxes (in constant 2015 US$) of Burundi in 1998 to that in 1999?
Give a very brief answer. 15.13. What is the ratio of the Taxes (in constant 2015 US$) of Micronesia in 1998 to that in 1999?
Make the answer very short. 0.87. What is the ratio of the Taxes (in constant 2015 US$) of Netherlands in 1998 to that in 1999?
Offer a very short reply. 0.95. What is the ratio of the Taxes (in constant 2015 US$) of New Zealand in 1998 to that in 1999?
Your answer should be compact. 0.96. What is the difference between the highest and the second highest Taxes (in constant 2015 US$) in Burundi?
Provide a short and direct response. 1.91e+07. What is the difference between the highest and the second highest Taxes (in constant 2015 US$) in Micronesia?
Your response must be concise. 1.82e+06. What is the difference between the highest and the second highest Taxes (in constant 2015 US$) of Netherlands?
Ensure brevity in your answer.  2.07e+09. What is the difference between the highest and the second highest Taxes (in constant 2015 US$) in New Zealand?
Offer a very short reply. 3.89e+08. What is the difference between the highest and the lowest Taxes (in constant 2015 US$) in Burundi?
Give a very brief answer. 1.23e+08. What is the difference between the highest and the lowest Taxes (in constant 2015 US$) of Micronesia?
Give a very brief answer. 7.96e+06. What is the difference between the highest and the lowest Taxes (in constant 2015 US$) in Netherlands?
Offer a very short reply. 3.48e+1. What is the difference between the highest and the lowest Taxes (in constant 2015 US$) of New Zealand?
Your answer should be very brief. 4.91e+09. 